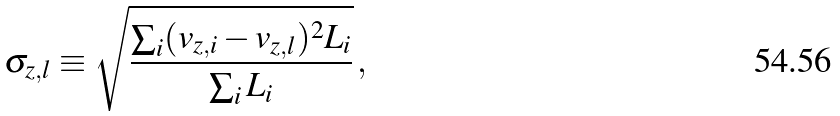Convert formula to latex. <formula><loc_0><loc_0><loc_500><loc_500>\sigma _ { z , l } \equiv \sqrt { \frac { \sum _ { i } ( v _ { z , i } - v _ { z , l } ) ^ { 2 } L _ { i } } { \sum _ { i } L _ { i } } } \, ,</formula> 